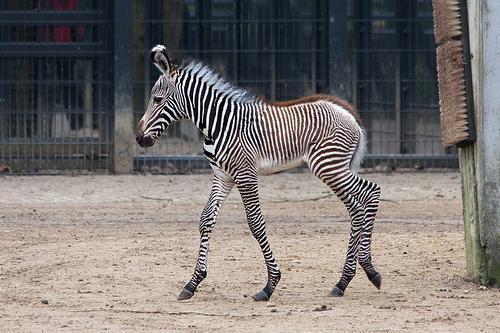How many zebras are there?
Give a very brief answer. 1. 